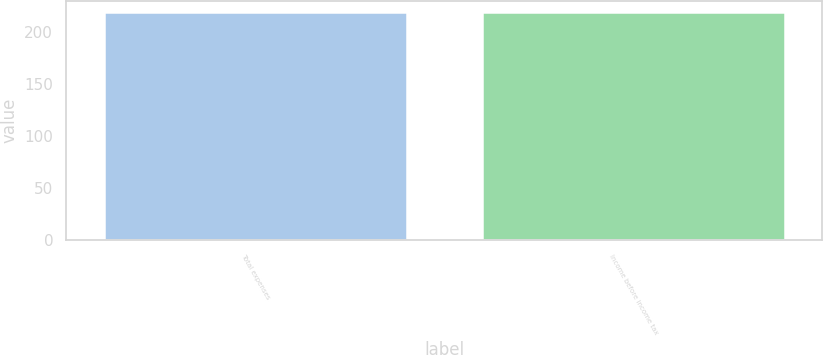<chart> <loc_0><loc_0><loc_500><loc_500><bar_chart><fcel>Total expenses<fcel>Income before income tax<nl><fcel>219<fcel>219.1<nl></chart> 